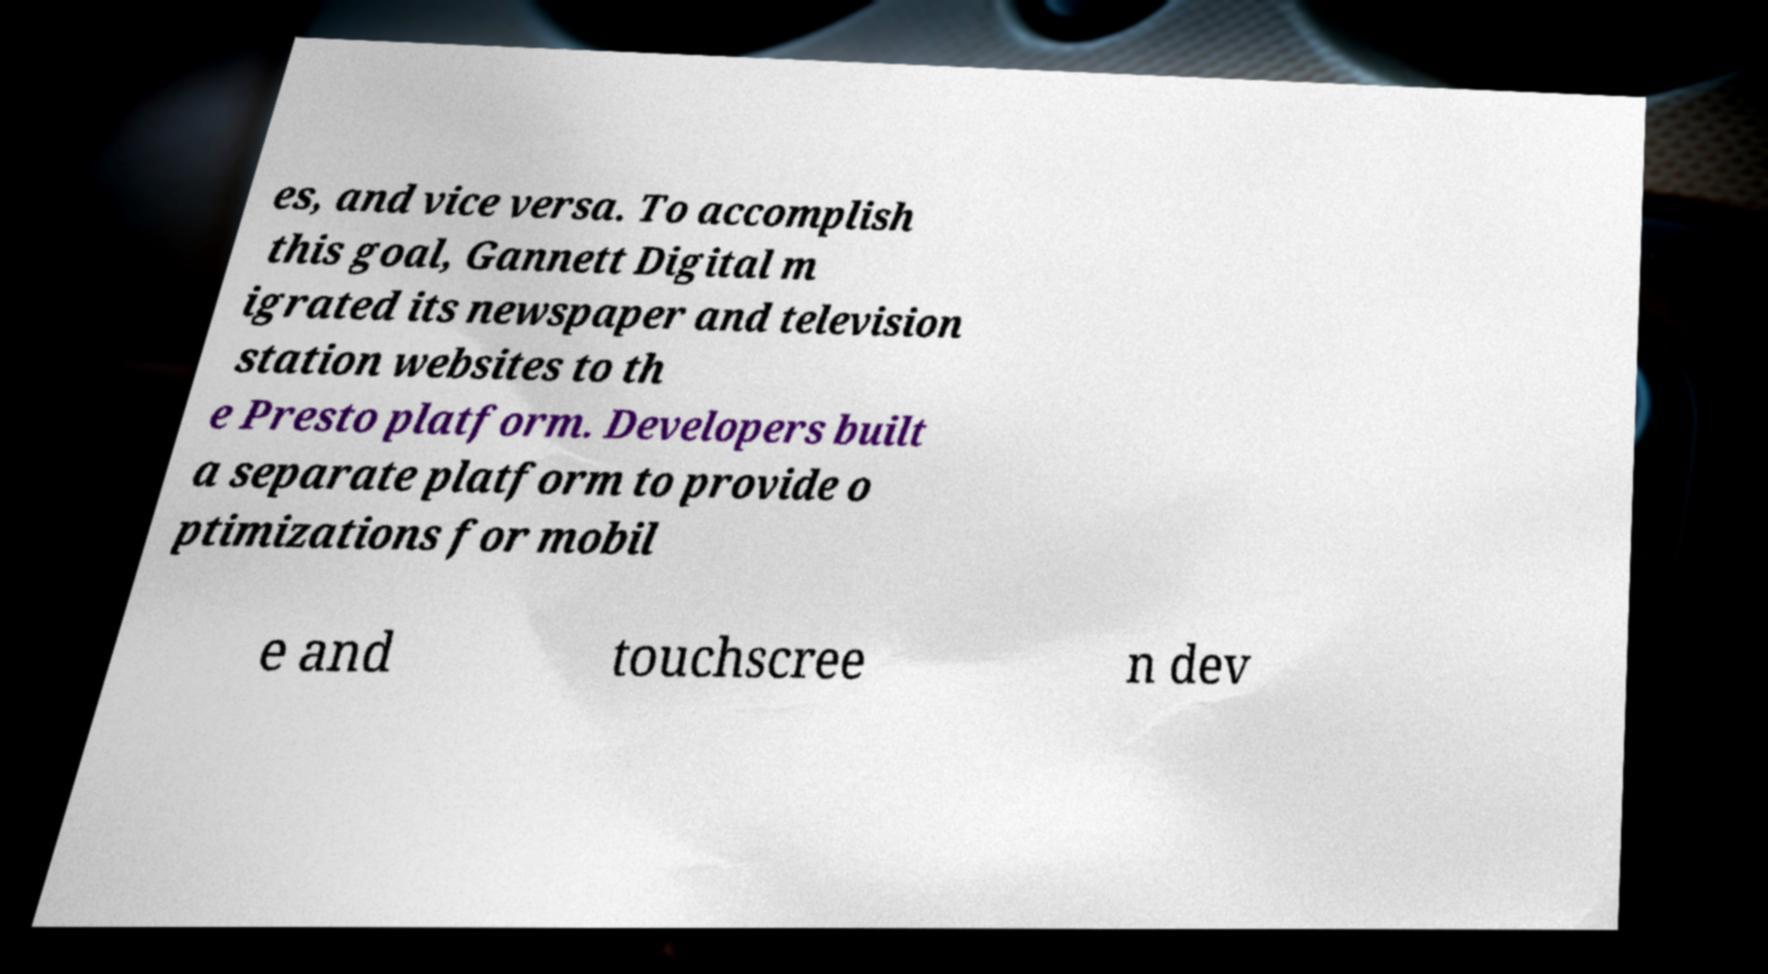Please identify and transcribe the text found in this image. es, and vice versa. To accomplish this goal, Gannett Digital m igrated its newspaper and television station websites to th e Presto platform. Developers built a separate platform to provide o ptimizations for mobil e and touchscree n dev 